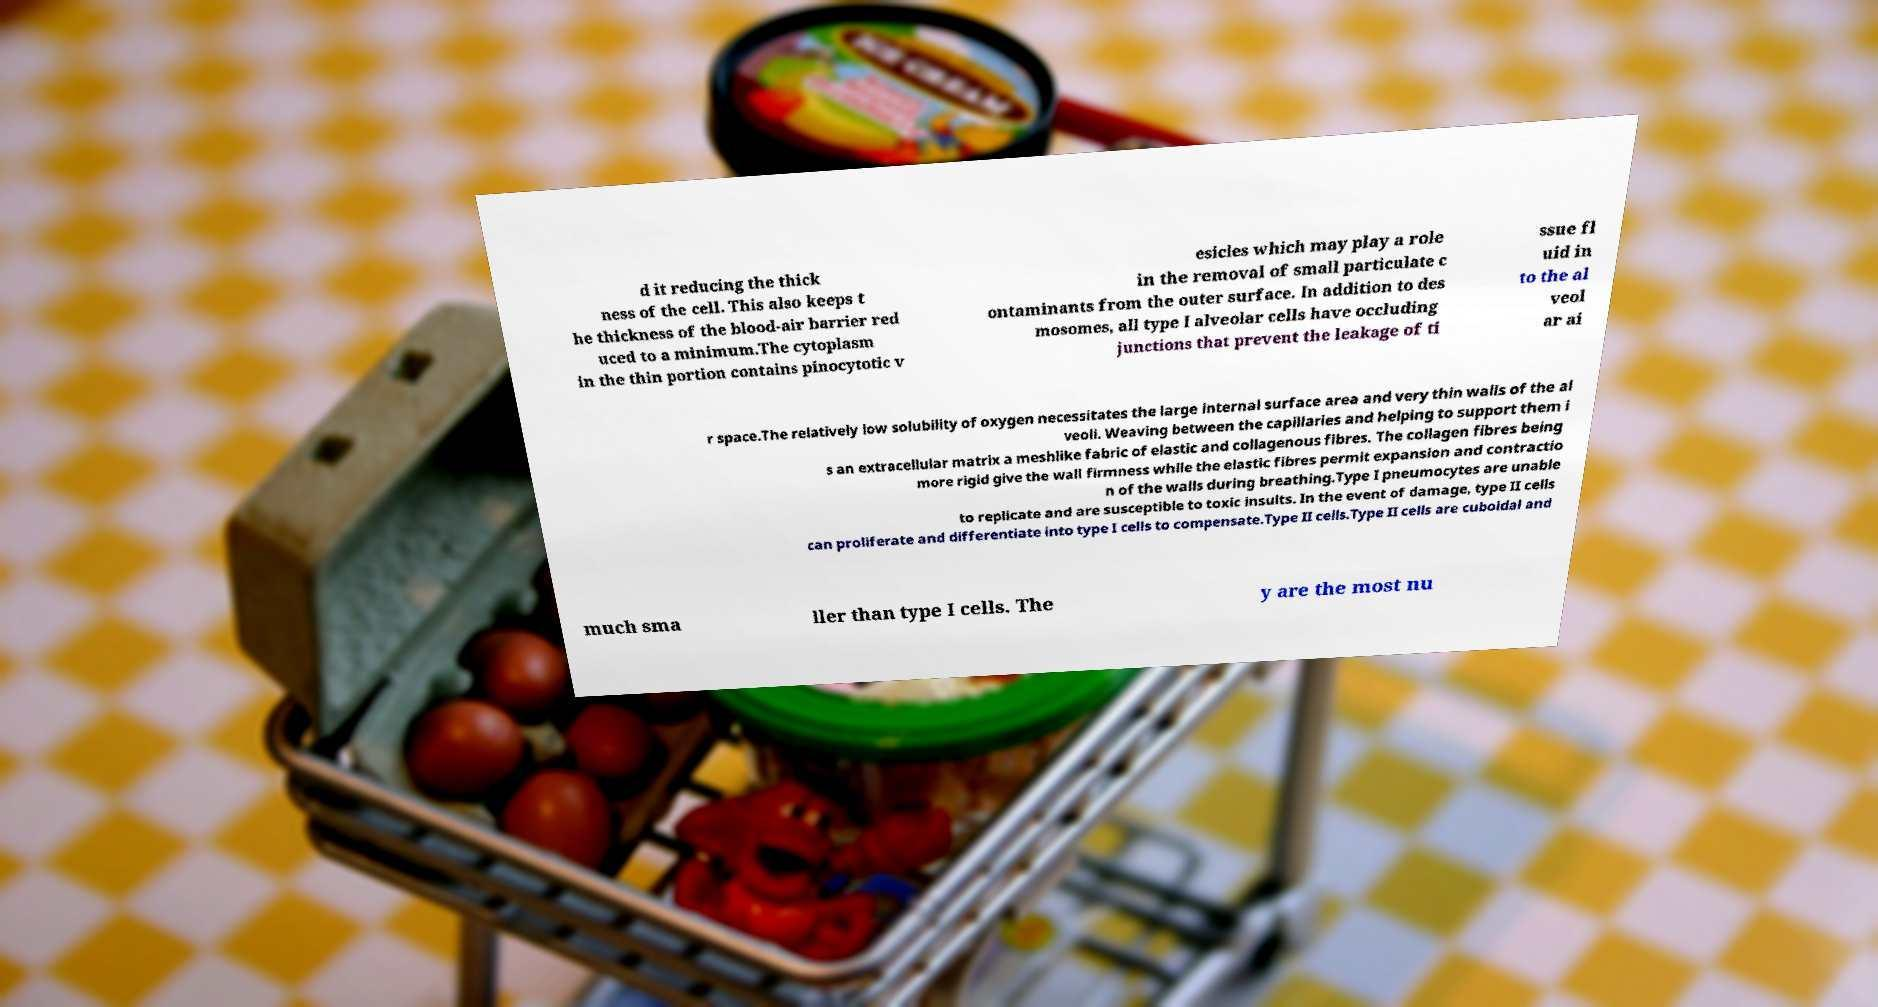There's text embedded in this image that I need extracted. Can you transcribe it verbatim? d it reducing the thick ness of the cell. This also keeps t he thickness of the blood-air barrier red uced to a minimum.The cytoplasm in the thin portion contains pinocytotic v esicles which may play a role in the removal of small particulate c ontaminants from the outer surface. In addition to des mosomes, all type I alveolar cells have occluding junctions that prevent the leakage of ti ssue fl uid in to the al veol ar ai r space.The relatively low solubility of oxygen necessitates the large internal surface area and very thin walls of the al veoli. Weaving between the capillaries and helping to support them i s an extracellular matrix a meshlike fabric of elastic and collagenous fibres. The collagen fibres being more rigid give the wall firmness while the elastic fibres permit expansion and contractio n of the walls during breathing.Type I pneumocytes are unable to replicate and are susceptible to toxic insults. In the event of damage, type II cells can proliferate and differentiate into type I cells to compensate.Type II cells.Type II cells are cuboidal and much sma ller than type I cells. The y are the most nu 